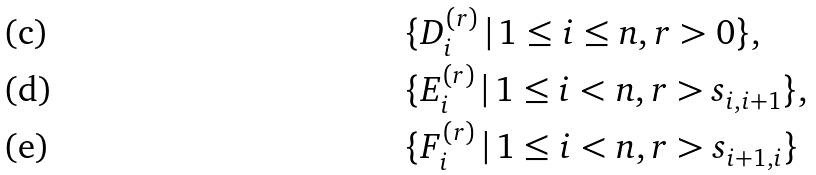Convert formula to latex. <formula><loc_0><loc_0><loc_500><loc_500>& \{ D _ { i } ^ { ( r ) } \, | \, 1 \leq i \leq n , r > 0 \} , \\ & \{ E _ { i } ^ { ( r ) } \, | \, 1 \leq i < n , r > s _ { i , i + 1 } \} , \\ & \{ F _ { i } ^ { ( r ) } \, | \, 1 \leq i < n , r > s _ { i + 1 , i } \}</formula> 